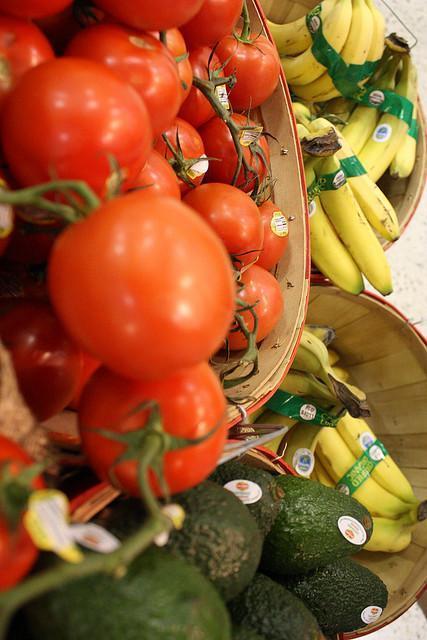How many bananas are in the photo?
Give a very brief answer. 6. 